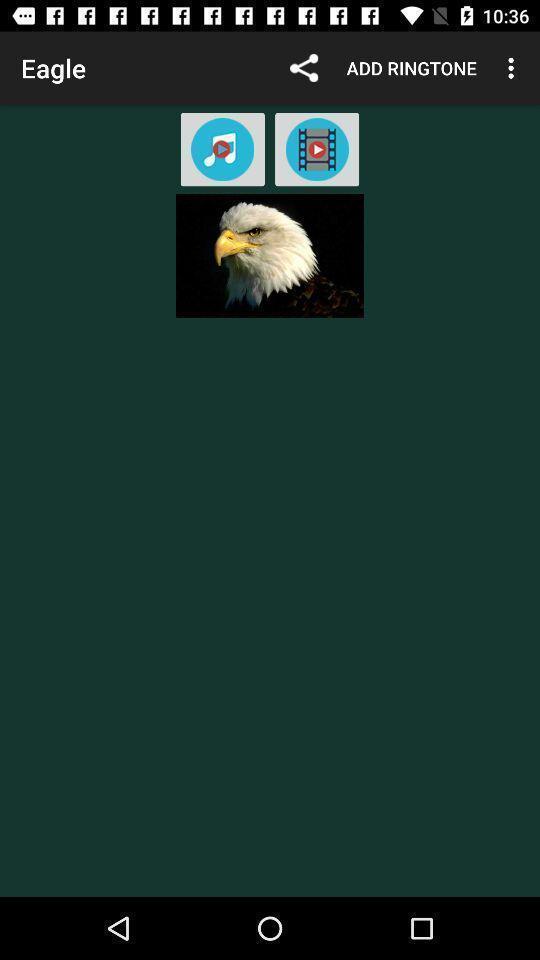Describe this image in words. Screen shows eagle image. 